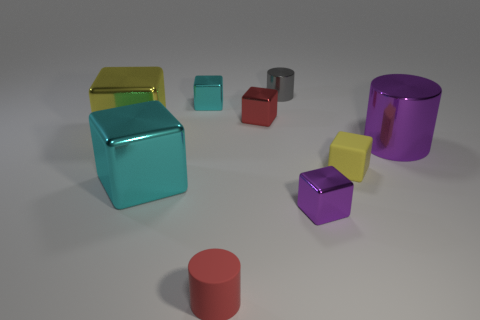Do the red rubber cylinder and the yellow metallic block have the same size?
Your response must be concise. No. How many things are either small gray cylinders or metal things behind the big yellow thing?
Give a very brief answer. 3. What is the material of the red cylinder that is the same size as the red cube?
Offer a very short reply. Rubber. There is a cylinder that is both left of the small yellow cube and in front of the tiny cyan thing; what is it made of?
Give a very brief answer. Rubber. Are there any cyan things that are in front of the tiny metallic object to the left of the small red cylinder?
Offer a terse response. Yes. What is the size of the cube that is both in front of the small red metallic block and behind the purple shiny cylinder?
Make the answer very short. Large. What number of purple objects are large cubes or tiny things?
Give a very brief answer. 1. What shape is the purple object that is the same size as the gray thing?
Offer a very short reply. Cube. What number of other things are the same color as the tiny metal cylinder?
Your answer should be very brief. 0. How big is the yellow object that is left of the rubber thing that is left of the small red shiny object?
Give a very brief answer. Large. 